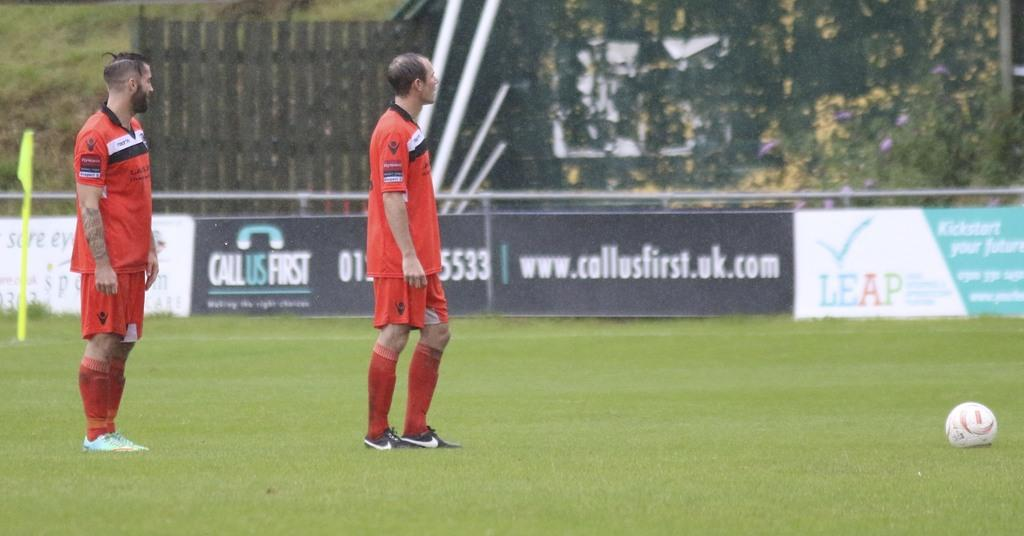<image>
Provide a brief description of the given image. Two soccer players stand on the field, with a wall that advertises Call Us First in the UK. 